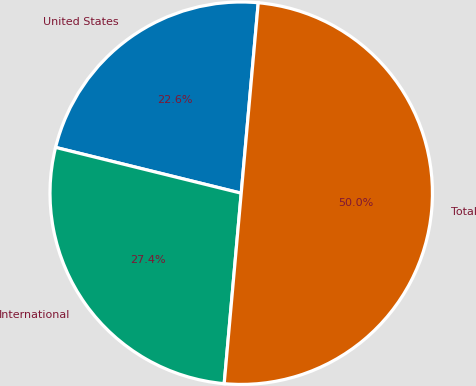Convert chart to OTSL. <chart><loc_0><loc_0><loc_500><loc_500><pie_chart><fcel>United States<fcel>International<fcel>Total<nl><fcel>22.57%<fcel>27.43%<fcel>50.0%<nl></chart> 